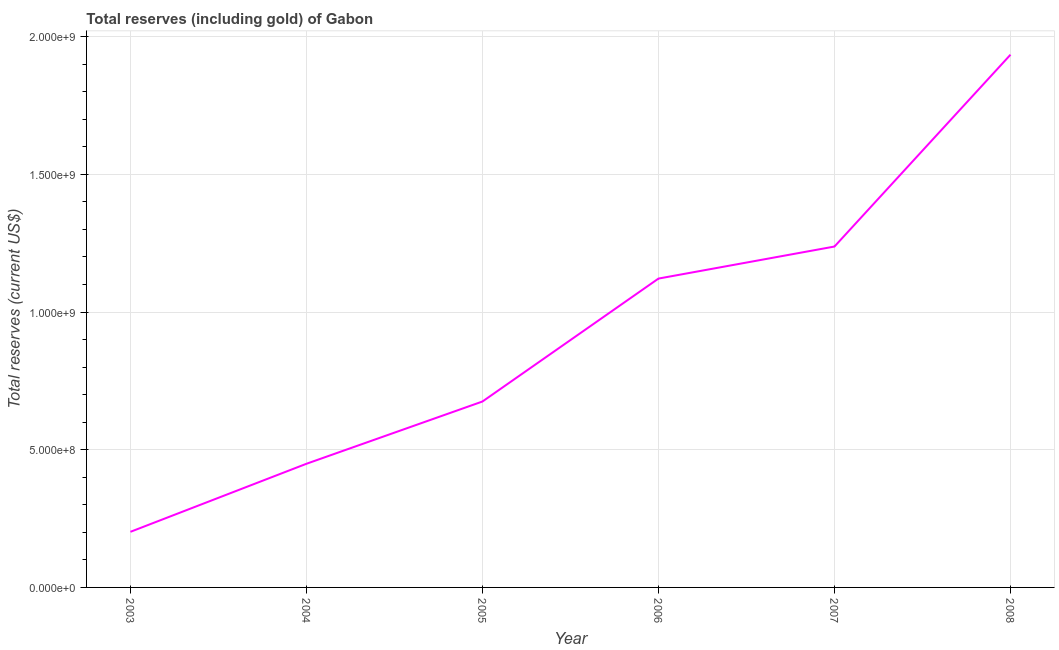What is the total reserves (including gold) in 2006?
Your answer should be very brief. 1.12e+09. Across all years, what is the maximum total reserves (including gold)?
Your answer should be compact. 1.93e+09. Across all years, what is the minimum total reserves (including gold)?
Provide a succinct answer. 2.02e+08. In which year was the total reserves (including gold) minimum?
Make the answer very short. 2003. What is the sum of the total reserves (including gold)?
Keep it short and to the point. 5.62e+09. What is the difference between the total reserves (including gold) in 2004 and 2008?
Offer a very short reply. -1.49e+09. What is the average total reserves (including gold) per year?
Give a very brief answer. 9.37e+08. What is the median total reserves (including gold)?
Ensure brevity in your answer.  8.98e+08. Do a majority of the years between 2006 and 2007 (inclusive) have total reserves (including gold) greater than 300000000 US$?
Your answer should be compact. Yes. What is the ratio of the total reserves (including gold) in 2003 to that in 2008?
Provide a succinct answer. 0.1. Is the total reserves (including gold) in 2005 less than that in 2006?
Your answer should be compact. Yes. Is the difference between the total reserves (including gold) in 2003 and 2007 greater than the difference between any two years?
Make the answer very short. No. What is the difference between the highest and the second highest total reserves (including gold)?
Your response must be concise. 6.97e+08. Is the sum of the total reserves (including gold) in 2004 and 2007 greater than the maximum total reserves (including gold) across all years?
Your answer should be compact. No. What is the difference between the highest and the lowest total reserves (including gold)?
Your response must be concise. 1.73e+09. In how many years, is the total reserves (including gold) greater than the average total reserves (including gold) taken over all years?
Ensure brevity in your answer.  3. Does the total reserves (including gold) monotonically increase over the years?
Your response must be concise. Yes. How many years are there in the graph?
Your answer should be very brief. 6. What is the difference between two consecutive major ticks on the Y-axis?
Offer a terse response. 5.00e+08. Does the graph contain any zero values?
Keep it short and to the point. No. What is the title of the graph?
Provide a succinct answer. Total reserves (including gold) of Gabon. What is the label or title of the Y-axis?
Your answer should be very brief. Total reserves (current US$). What is the Total reserves (current US$) of 2003?
Ensure brevity in your answer.  2.02e+08. What is the Total reserves (current US$) of 2004?
Make the answer very short. 4.49e+08. What is the Total reserves (current US$) in 2005?
Your response must be concise. 6.75e+08. What is the Total reserves (current US$) of 2006?
Ensure brevity in your answer.  1.12e+09. What is the Total reserves (current US$) of 2007?
Offer a very short reply. 1.24e+09. What is the Total reserves (current US$) of 2008?
Your answer should be very brief. 1.93e+09. What is the difference between the Total reserves (current US$) in 2003 and 2004?
Provide a short and direct response. -2.47e+08. What is the difference between the Total reserves (current US$) in 2003 and 2005?
Your answer should be compact. -4.73e+08. What is the difference between the Total reserves (current US$) in 2003 and 2006?
Offer a very short reply. -9.20e+08. What is the difference between the Total reserves (current US$) in 2003 and 2007?
Ensure brevity in your answer.  -1.04e+09. What is the difference between the Total reserves (current US$) in 2003 and 2008?
Your answer should be compact. -1.73e+09. What is the difference between the Total reserves (current US$) in 2004 and 2005?
Provide a succinct answer. -2.26e+08. What is the difference between the Total reserves (current US$) in 2004 and 2006?
Ensure brevity in your answer.  -6.73e+08. What is the difference between the Total reserves (current US$) in 2004 and 2007?
Offer a very short reply. -7.89e+08. What is the difference between the Total reserves (current US$) in 2004 and 2008?
Give a very brief answer. -1.49e+09. What is the difference between the Total reserves (current US$) in 2005 and 2006?
Provide a short and direct response. -4.46e+08. What is the difference between the Total reserves (current US$) in 2005 and 2007?
Ensure brevity in your answer.  -5.63e+08. What is the difference between the Total reserves (current US$) in 2005 and 2008?
Your response must be concise. -1.26e+09. What is the difference between the Total reserves (current US$) in 2006 and 2007?
Your response must be concise. -1.16e+08. What is the difference between the Total reserves (current US$) in 2006 and 2008?
Your answer should be compact. -8.13e+08. What is the difference between the Total reserves (current US$) in 2007 and 2008?
Your response must be concise. -6.97e+08. What is the ratio of the Total reserves (current US$) in 2003 to that in 2004?
Give a very brief answer. 0.45. What is the ratio of the Total reserves (current US$) in 2003 to that in 2005?
Offer a terse response. 0.3. What is the ratio of the Total reserves (current US$) in 2003 to that in 2006?
Keep it short and to the point. 0.18. What is the ratio of the Total reserves (current US$) in 2003 to that in 2007?
Your answer should be very brief. 0.16. What is the ratio of the Total reserves (current US$) in 2003 to that in 2008?
Keep it short and to the point. 0.1. What is the ratio of the Total reserves (current US$) in 2004 to that in 2005?
Ensure brevity in your answer.  0.67. What is the ratio of the Total reserves (current US$) in 2004 to that in 2006?
Provide a short and direct response. 0.4. What is the ratio of the Total reserves (current US$) in 2004 to that in 2007?
Your response must be concise. 0.36. What is the ratio of the Total reserves (current US$) in 2004 to that in 2008?
Your response must be concise. 0.23. What is the ratio of the Total reserves (current US$) in 2005 to that in 2006?
Offer a very short reply. 0.6. What is the ratio of the Total reserves (current US$) in 2005 to that in 2007?
Make the answer very short. 0.55. What is the ratio of the Total reserves (current US$) in 2005 to that in 2008?
Offer a terse response. 0.35. What is the ratio of the Total reserves (current US$) in 2006 to that in 2007?
Your response must be concise. 0.91. What is the ratio of the Total reserves (current US$) in 2006 to that in 2008?
Provide a succinct answer. 0.58. What is the ratio of the Total reserves (current US$) in 2007 to that in 2008?
Provide a short and direct response. 0.64. 